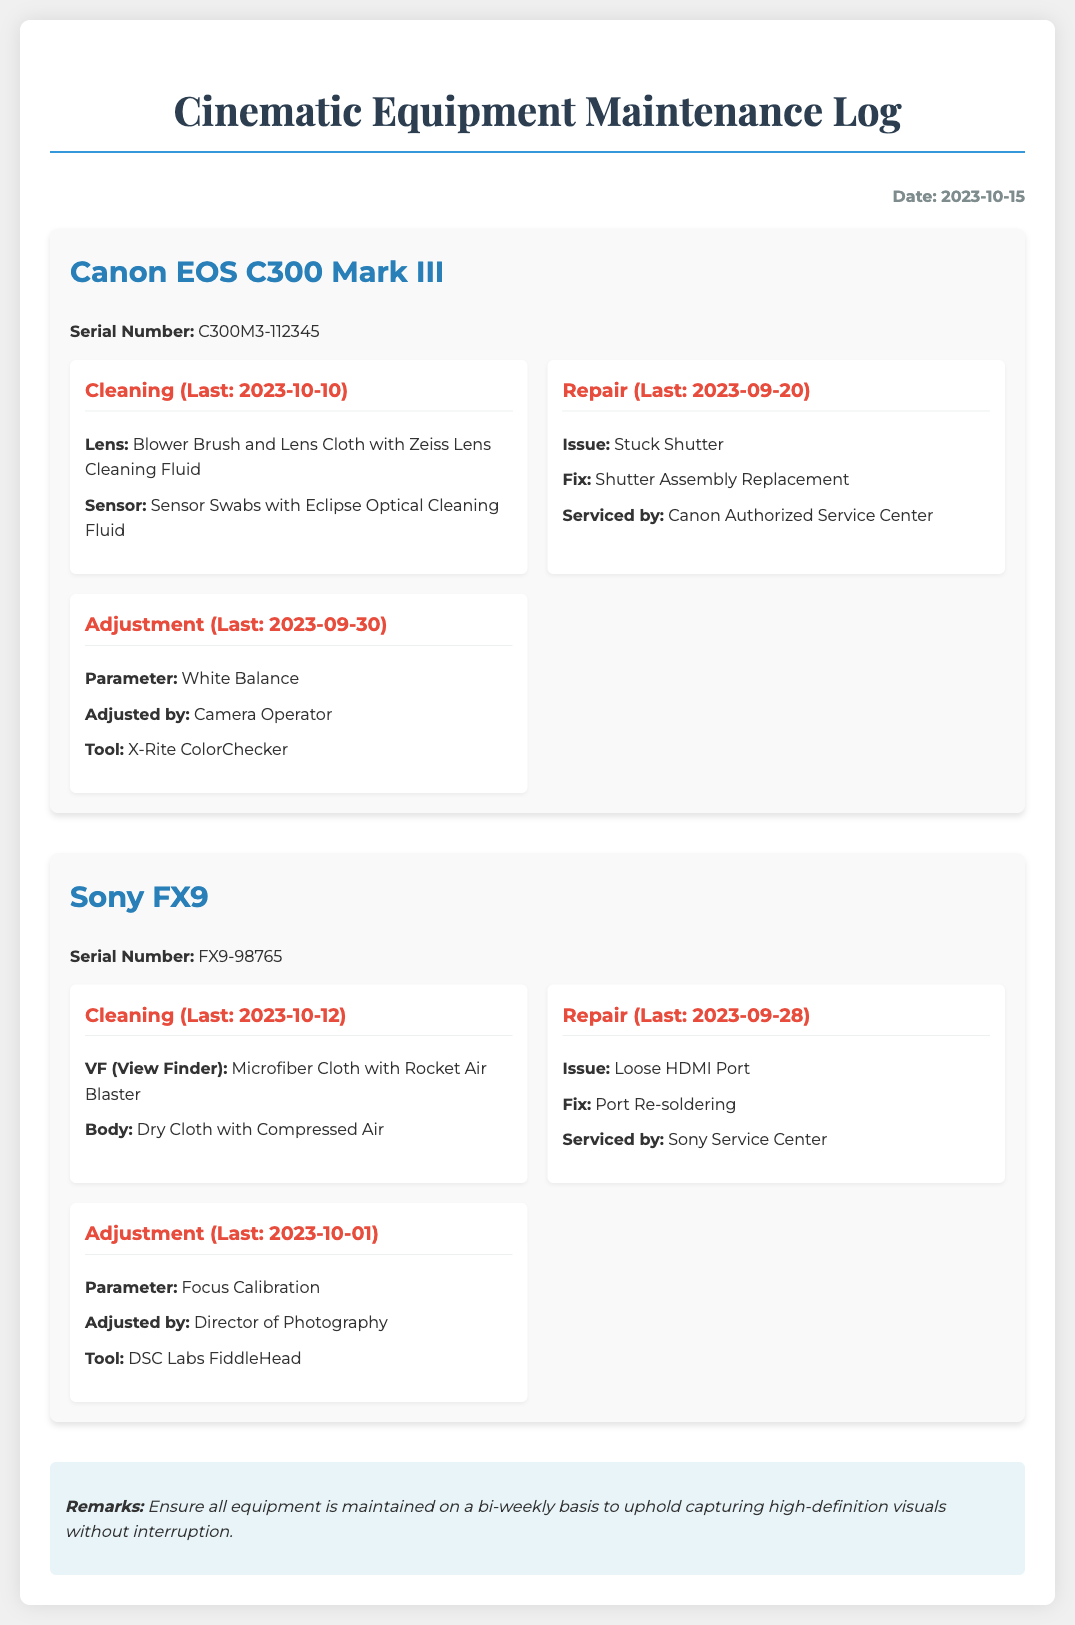What is the serial number of the Canon EOS C300 Mark III? The serial number is listed under the Canon EOS C300 Mark III equipment.
Answer: C300M3-112345 When was the last cleaning performed on the Sony FX9? The last cleaning date is mentioned in the Sony FX9 section of the document.
Answer: 2023-10-12 What was the issue reported for the Canon EOS C300 Mark III? The issue is described in the repair section of the Canon EOS C300 Mark III equipment.
Answer: Stuck Shutter Who serviced the Sony FX9 for the loose HDMI port repair? The servicing entity is specified in the repair section of the Sony FX9.
Answer: Sony Service Center What tool was used for the white balance adjustment in the Canon EOS C300 Mark III? The tool used for the adjustment is mentioned in the adjustment section of the Canon EOS C300 Mark III.
Answer: X-Rite ColorChecker What is the recommended maintenance frequency for the equipment? The recommendation is found in the remarks section of the document.
Answer: Bi-weekly Which equipment had a focus calibration adjustment last done? The adjustment details are provided for both equipment sections; identifying the one is needed.
Answer: Sony FX9 What was the fix for the loose HDMI port on the Sony FX9? The fix is indicated in the repair details of the Sony FX9.
Answer: Port Re-soldering Who performed the focus calibration on the Sony FX9? The person who adjusted the focus is stated in the adjustment section of the Sony FX9.
Answer: Director of Photography 